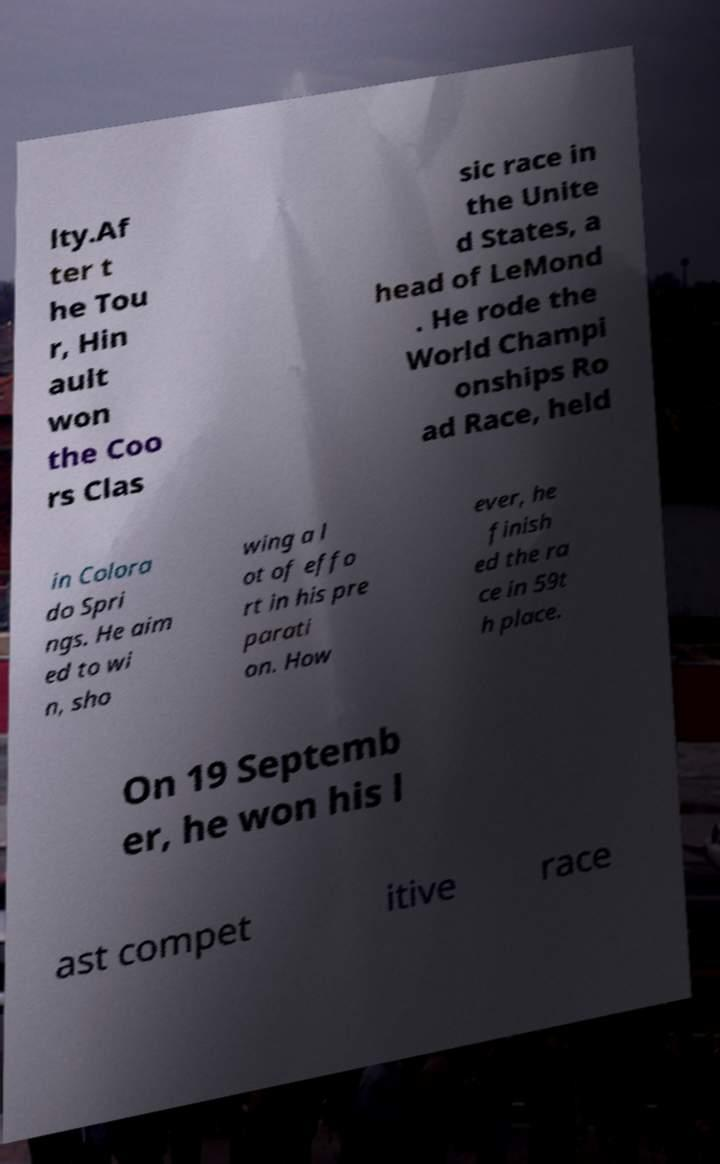Could you assist in decoding the text presented in this image and type it out clearly? lty.Af ter t he Tou r, Hin ault won the Coo rs Clas sic race in the Unite d States, a head of LeMond . He rode the World Champi onships Ro ad Race, held in Colora do Spri ngs. He aim ed to wi n, sho wing a l ot of effo rt in his pre parati on. How ever, he finish ed the ra ce in 59t h place. On 19 Septemb er, he won his l ast compet itive race 